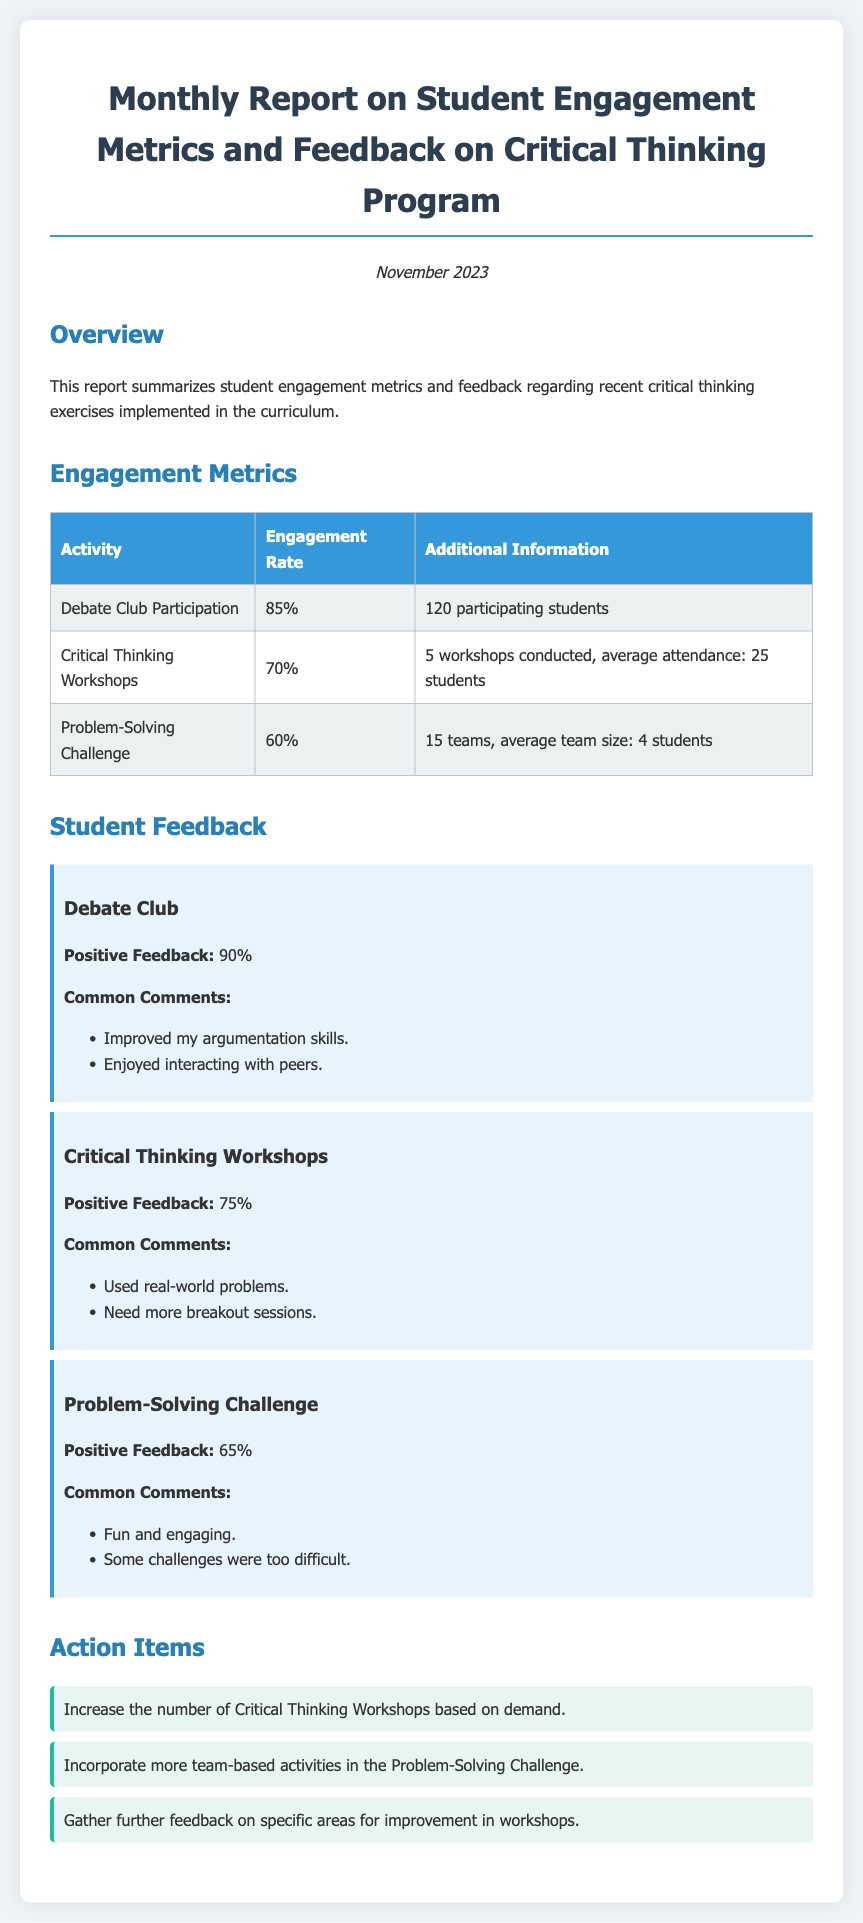what is the engagement rate for Debate Club Participation? The engagement rate is found in the Engagement Metrics section, specifically under Debate Club Participation, which states 85%.
Answer: 85% how many workshops were conducted for Critical Thinking Workshops? The number of workshops is specified in the Engagement Metrics, where it states 5 workshops conducted.
Answer: 5 what percentage of students provided positive feedback for the Problem-Solving Challenge? The positive feedback percentage for the Problem-Solving Challenge is indicated in the Student Feedback section, which is 65%.
Answer: 65% what common comment was made about the Critical Thinking Workshops? Common comments about the Critical Thinking Workshops are listed in the Student Feedback section, one of which is "Need more breakout sessions."
Answer: Need more breakout sessions which activity had the highest positive feedback percentage? The activity with the highest positive feedback percentage can be found in the Student Feedback section, with Debate Club having 90%.
Answer: Debate Club what is the average attendance for Critical Thinking Workshops? The average attendance is detailed in the Engagement Metrics section, which states average attendance: 25 students.
Answer: 25 students how many teams participated in the Problem-Solving Challenge? The number of teams that participated is outlined in the Engagement Metrics, which cites 15 teams participating.
Answer: 15 teams what action item suggests gathering further feedback? The action item regarding further feedback can be found in the Action Items section, specifically stating "Gather further feedback on specific areas for improvement in workshops."
Answer: Gather further feedback on specific areas for improvement in workshops 